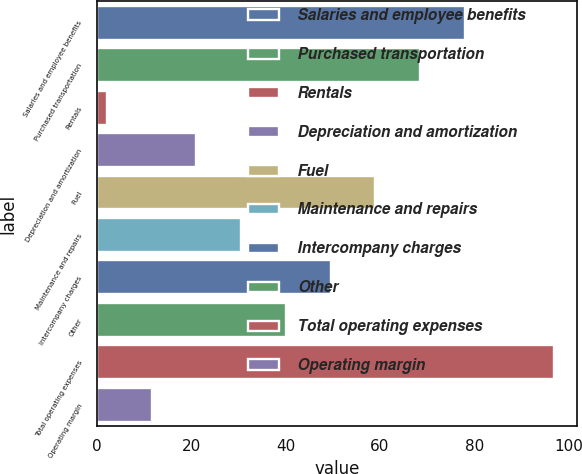Convert chart to OTSL. <chart><loc_0><loc_0><loc_500><loc_500><bar_chart><fcel>Salaries and employee benefits<fcel>Purchased transportation<fcel>Rentals<fcel>Depreciation and amortization<fcel>Fuel<fcel>Maintenance and repairs<fcel>Intercompany charges<fcel>Other<fcel>Total operating expenses<fcel>Operating margin<nl><fcel>77.96<fcel>68.49<fcel>2.2<fcel>21.14<fcel>59.02<fcel>30.61<fcel>49.55<fcel>40.08<fcel>96.9<fcel>11.67<nl></chart> 